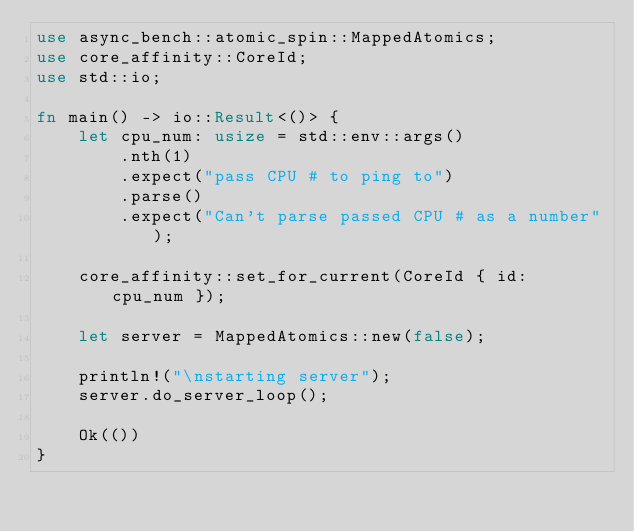Convert code to text. <code><loc_0><loc_0><loc_500><loc_500><_Rust_>use async_bench::atomic_spin::MappedAtomics;
use core_affinity::CoreId;
use std::io;

fn main() -> io::Result<()> {
    let cpu_num: usize = std::env::args()
        .nth(1)
        .expect("pass CPU # to ping to")
        .parse()
        .expect("Can't parse passed CPU # as a number");

    core_affinity::set_for_current(CoreId { id: cpu_num });

    let server = MappedAtomics::new(false);

    println!("\nstarting server");
    server.do_server_loop();

    Ok(())
}
</code> 